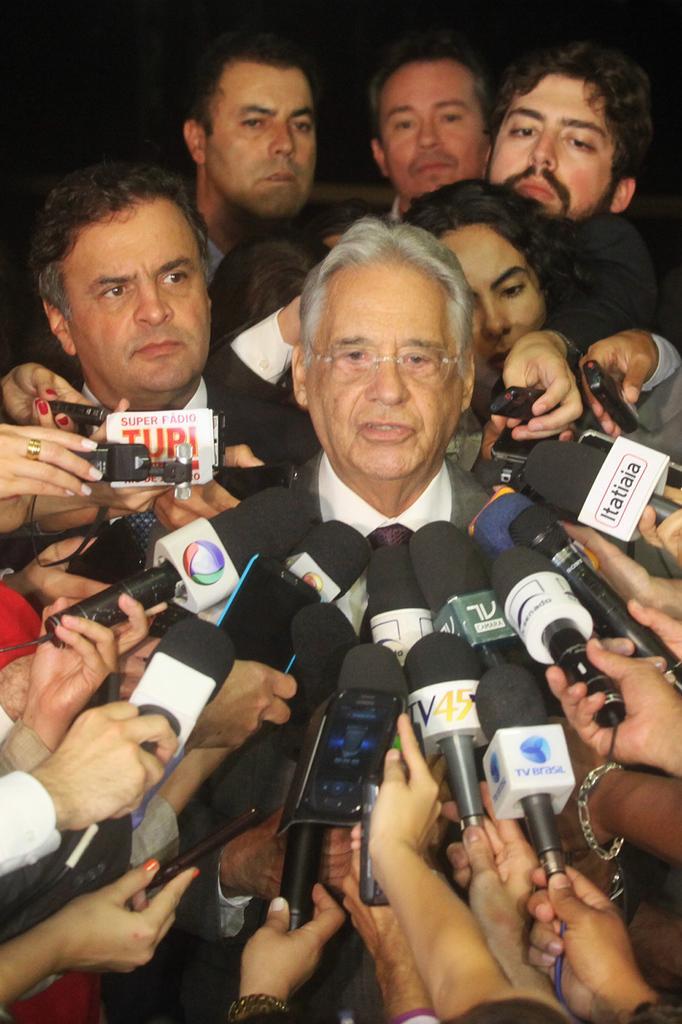In one or two sentences, can you explain what this image depicts? In this image I can see few people standing. Here many people are holding mikes in the hands and a man is speaking. 